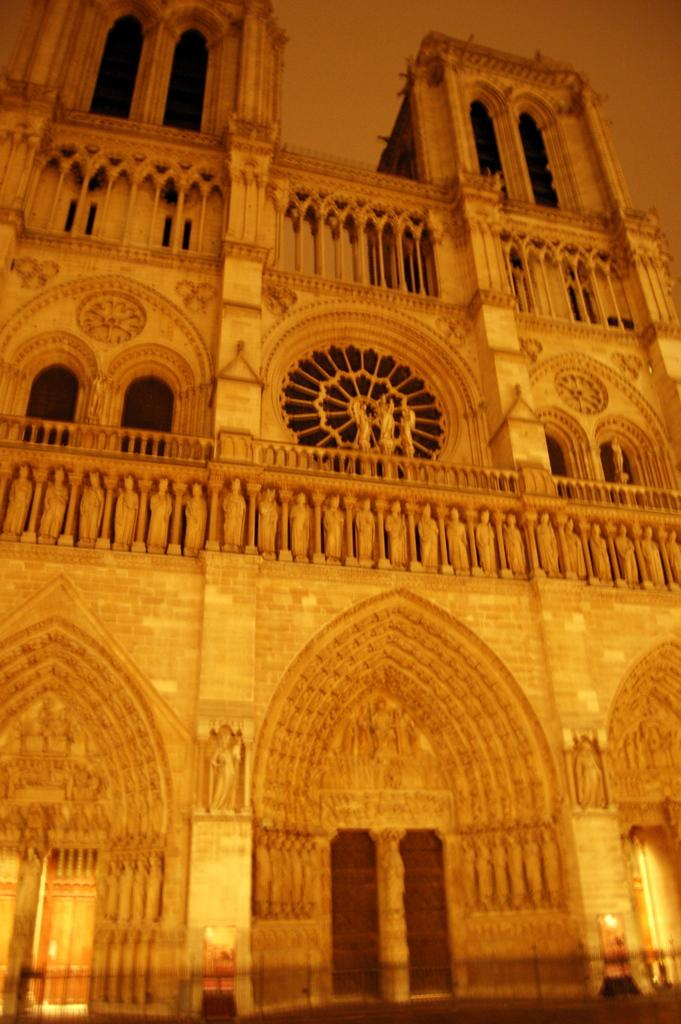What type of structure is in the image? There is a historical building in the image. What artistic features can be seen on the building? The building has sculptures and designs. What is the reaction of the land to the historical building in the image? The land does not have a reaction to the historical building in the image, as land is an inanimate object and cannot have reactions. 